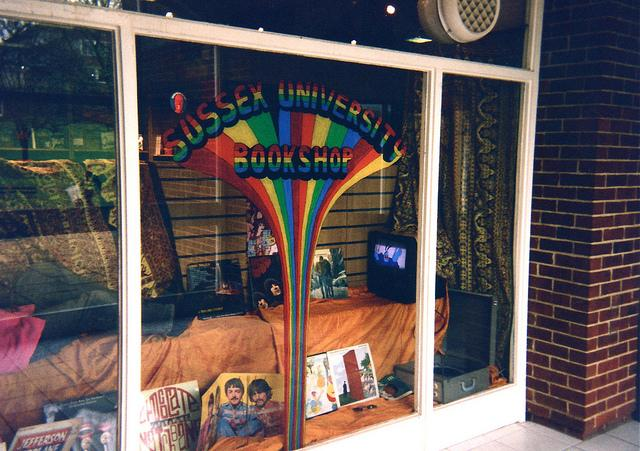What type of clientele does the book store have? students 